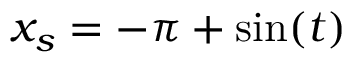Convert formula to latex. <formula><loc_0><loc_0><loc_500><loc_500>x _ { s } = - \pi + \sin ( t )</formula> 